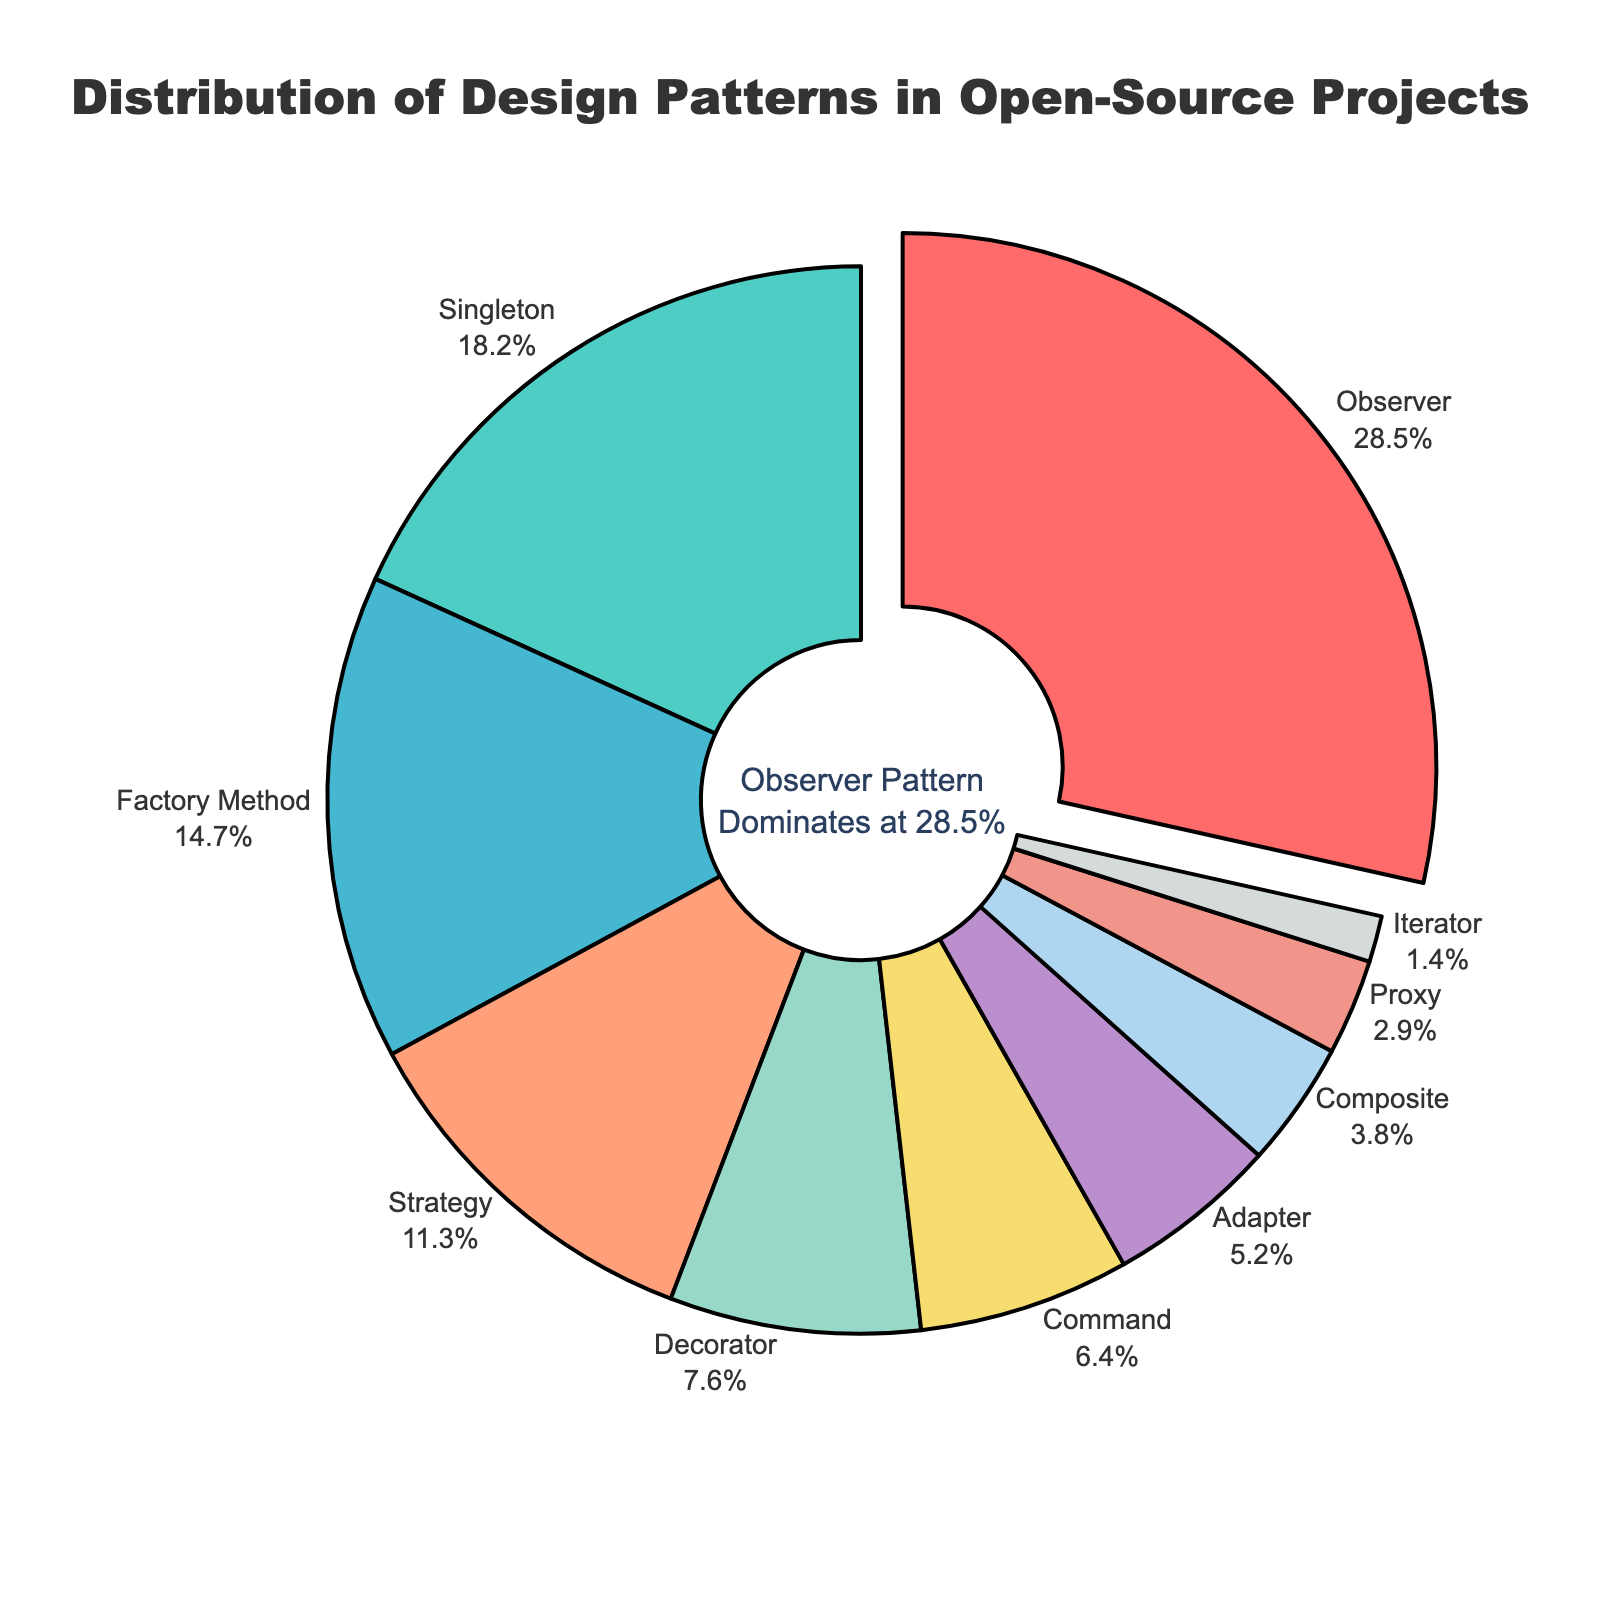Which design pattern has the highest usage percentage? The slice with the label "Observer" and 28.5% is pulled out, indicating it's the most prevalent design pattern.
Answer: Observer What is the second most used design pattern in open-source projects? The slice labeled "Singleton" shows 18.2%, which is the highest after the "Observer" pattern.
Answer: Singleton Which design pattern has a usage percentage closest to 10%? The pattern labeled "Strategy" has a usage percentage of 11.3%, which is closest to 10%.
Answer: Strategy How much more prevalent is the Observer pattern compared to the Strategy pattern? The usage percentage of the Observer pattern is 28.5%, and the Strategy pattern is 11.3%. Calculate the difference: 28.5% - 11.3% = 17.2%.
Answer: 17.2% If the usage percentages of Singleton and Factory Method were combined, would they exceed the percentage of the Observer pattern? Adding the percentages of Singleton (18.2%) and Factory Method (14.7%) gives 32.9%. Since 32.9% is greater than 28.5%, their combined usage exceeds the Observer pattern.
Answer: Yes Which pattern has a usage percentage less than 5% but greater than Adapter? The slice labeled "Composite" shows 3.8%, which meets the criteria (less than 5% but greater than Adapter's 5.2%).
Answer: Composite What is the total percentage of usage for the bottom three design patterns? The usage percentages for the bottom three are: Proxy (2.9%), Composite (3.8%), and Iterator (1.4%). Summing them: 2.9% + 3.8% + 1.4% = 8.1%.
Answer: 8.1% How many design patterns have a usage percentage higher than 10%? The patterns with percentages higher than 10% are: Observer (28.5%), Singleton (18.2%), Factory Method (14.7%), and Strategy (11.3%).
Answer: 4 What is the combined usage percentage of all design patterns that have a higher usage rate than Adapter? Patterns with usage higher than Adapter (5.2%): Observer (28.5%), Singleton (18.2%), Factory Method (14.7%), Strategy (11.3%), Decorator (7.6%), Command (6.4%). Sum: 28.5% + 18.2% + 14.7% + 11.3% + 7.6% + 6.4% = 86.7%.
Answer: 86.7% Which slice in the pie chart is the smallest by percentage? The slice labeled "Iterator" has the smallest percentage at 1.4%.
Answer: Iterator 